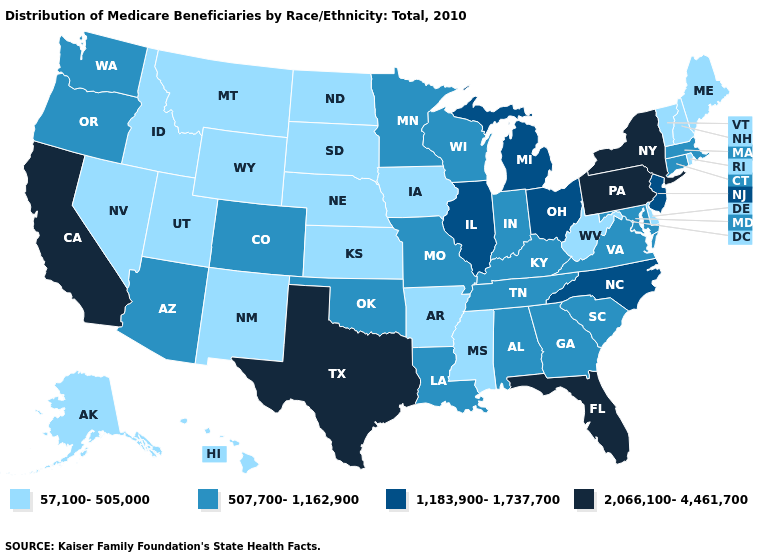Does the map have missing data?
Short answer required. No. Which states have the highest value in the USA?
Short answer required. California, Florida, New York, Pennsylvania, Texas. Name the states that have a value in the range 2,066,100-4,461,700?
Quick response, please. California, Florida, New York, Pennsylvania, Texas. Name the states that have a value in the range 507,700-1,162,900?
Quick response, please. Alabama, Arizona, Colorado, Connecticut, Georgia, Indiana, Kentucky, Louisiana, Maryland, Massachusetts, Minnesota, Missouri, Oklahoma, Oregon, South Carolina, Tennessee, Virginia, Washington, Wisconsin. What is the lowest value in the West?
Give a very brief answer. 57,100-505,000. Does the map have missing data?
Write a very short answer. No. Does Texas have the same value as California?
Quick response, please. Yes. Name the states that have a value in the range 1,183,900-1,737,700?
Answer briefly. Illinois, Michigan, New Jersey, North Carolina, Ohio. Does Pennsylvania have the highest value in the USA?
Quick response, please. Yes. Name the states that have a value in the range 507,700-1,162,900?
Be succinct. Alabama, Arizona, Colorado, Connecticut, Georgia, Indiana, Kentucky, Louisiana, Maryland, Massachusetts, Minnesota, Missouri, Oklahoma, Oregon, South Carolina, Tennessee, Virginia, Washington, Wisconsin. Is the legend a continuous bar?
Write a very short answer. No. Does Illinois have a higher value than Michigan?
Be succinct. No. Name the states that have a value in the range 1,183,900-1,737,700?
Quick response, please. Illinois, Michigan, New Jersey, North Carolina, Ohio. Does Minnesota have the highest value in the USA?
Be succinct. No. What is the value of Washington?
Write a very short answer. 507,700-1,162,900. 